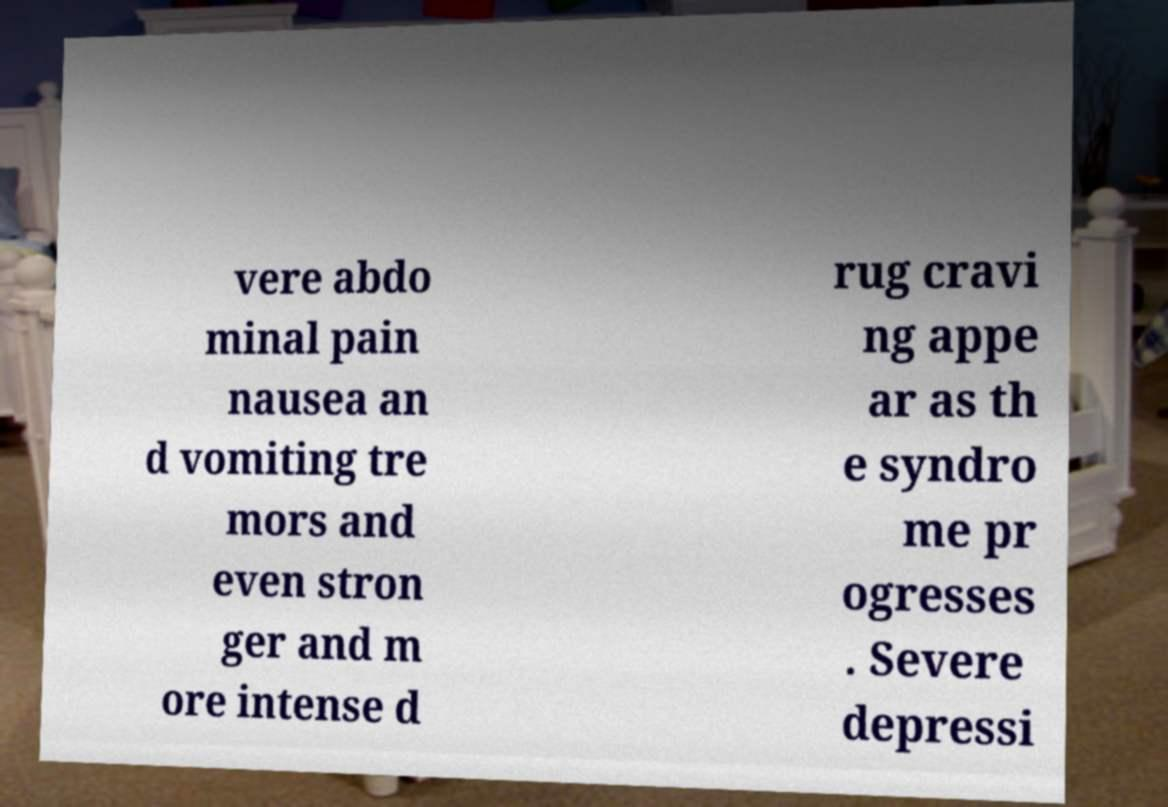Please identify and transcribe the text found in this image. vere abdo minal pain nausea an d vomiting tre mors and even stron ger and m ore intense d rug cravi ng appe ar as th e syndro me pr ogresses . Severe depressi 